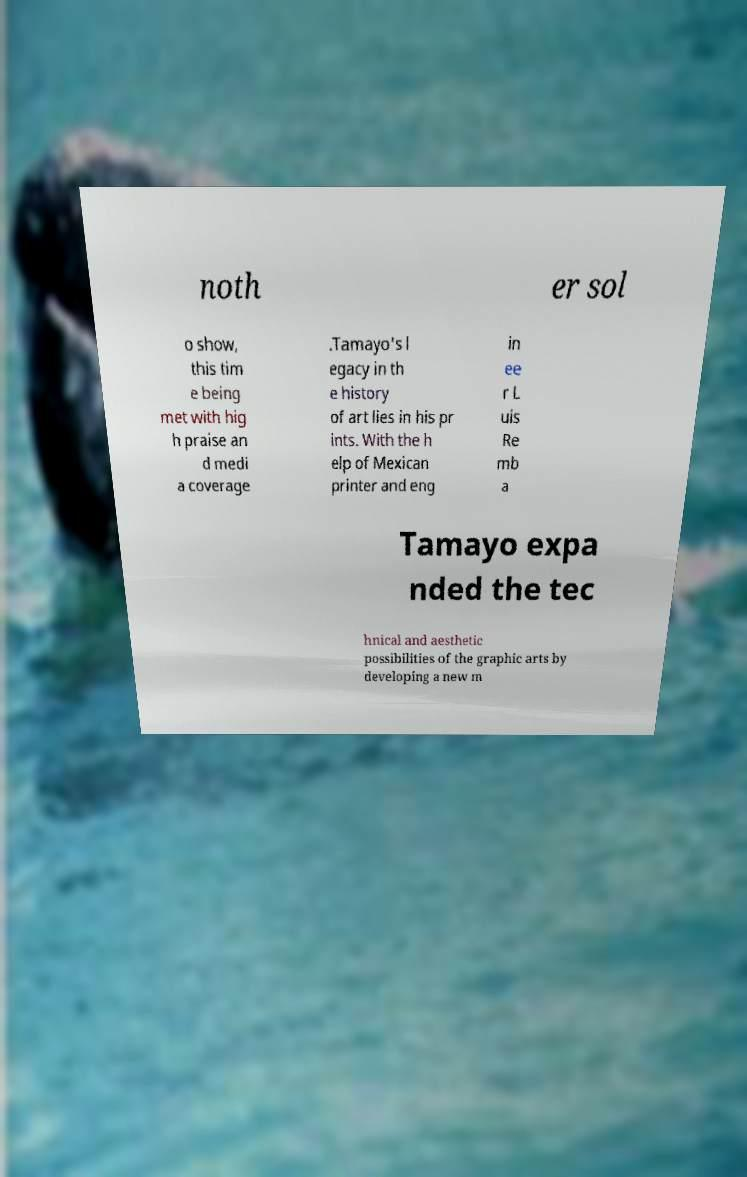Can you read and provide the text displayed in the image?This photo seems to have some interesting text. Can you extract and type it out for me? noth er sol o show, this tim e being met with hig h praise an d medi a coverage .Tamayo's l egacy in th e history of art lies in his pr ints. With the h elp of Mexican printer and eng in ee r L uis Re mb a Tamayo expa nded the tec hnical and aesthetic possibilities of the graphic arts by developing a new m 